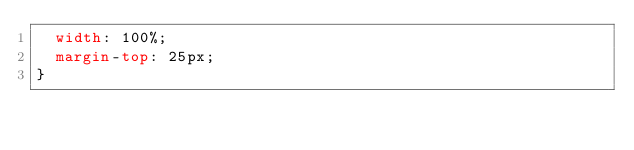Convert code to text. <code><loc_0><loc_0><loc_500><loc_500><_CSS_>  width: 100%;
  margin-top: 25px;
}
</code> 